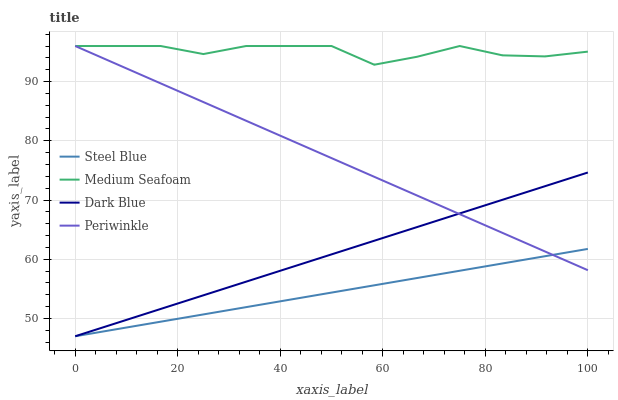Does Steel Blue have the minimum area under the curve?
Answer yes or no. Yes. Does Medium Seafoam have the maximum area under the curve?
Answer yes or no. Yes. Does Periwinkle have the minimum area under the curve?
Answer yes or no. No. Does Periwinkle have the maximum area under the curve?
Answer yes or no. No. Is Periwinkle the smoothest?
Answer yes or no. Yes. Is Medium Seafoam the roughest?
Answer yes or no. Yes. Is Steel Blue the smoothest?
Answer yes or no. No. Is Steel Blue the roughest?
Answer yes or no. No. Does Dark Blue have the lowest value?
Answer yes or no. Yes. Does Periwinkle have the lowest value?
Answer yes or no. No. Does Medium Seafoam have the highest value?
Answer yes or no. Yes. Does Steel Blue have the highest value?
Answer yes or no. No. Is Dark Blue less than Medium Seafoam?
Answer yes or no. Yes. Is Medium Seafoam greater than Dark Blue?
Answer yes or no. Yes. Does Dark Blue intersect Steel Blue?
Answer yes or no. Yes. Is Dark Blue less than Steel Blue?
Answer yes or no. No. Is Dark Blue greater than Steel Blue?
Answer yes or no. No. Does Dark Blue intersect Medium Seafoam?
Answer yes or no. No. 